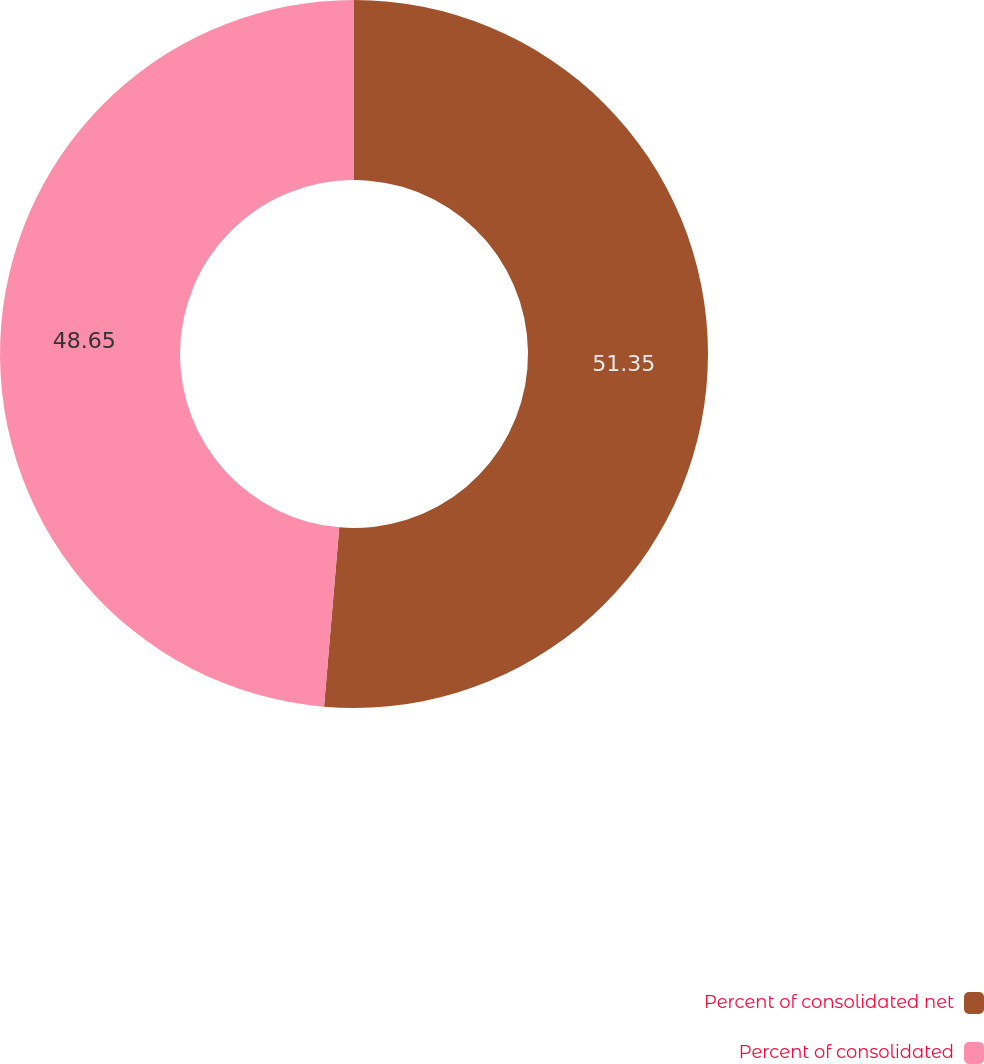Convert chart. <chart><loc_0><loc_0><loc_500><loc_500><pie_chart><fcel>Percent of consolidated net<fcel>Percent of consolidated<nl><fcel>51.35%<fcel>48.65%<nl></chart> 